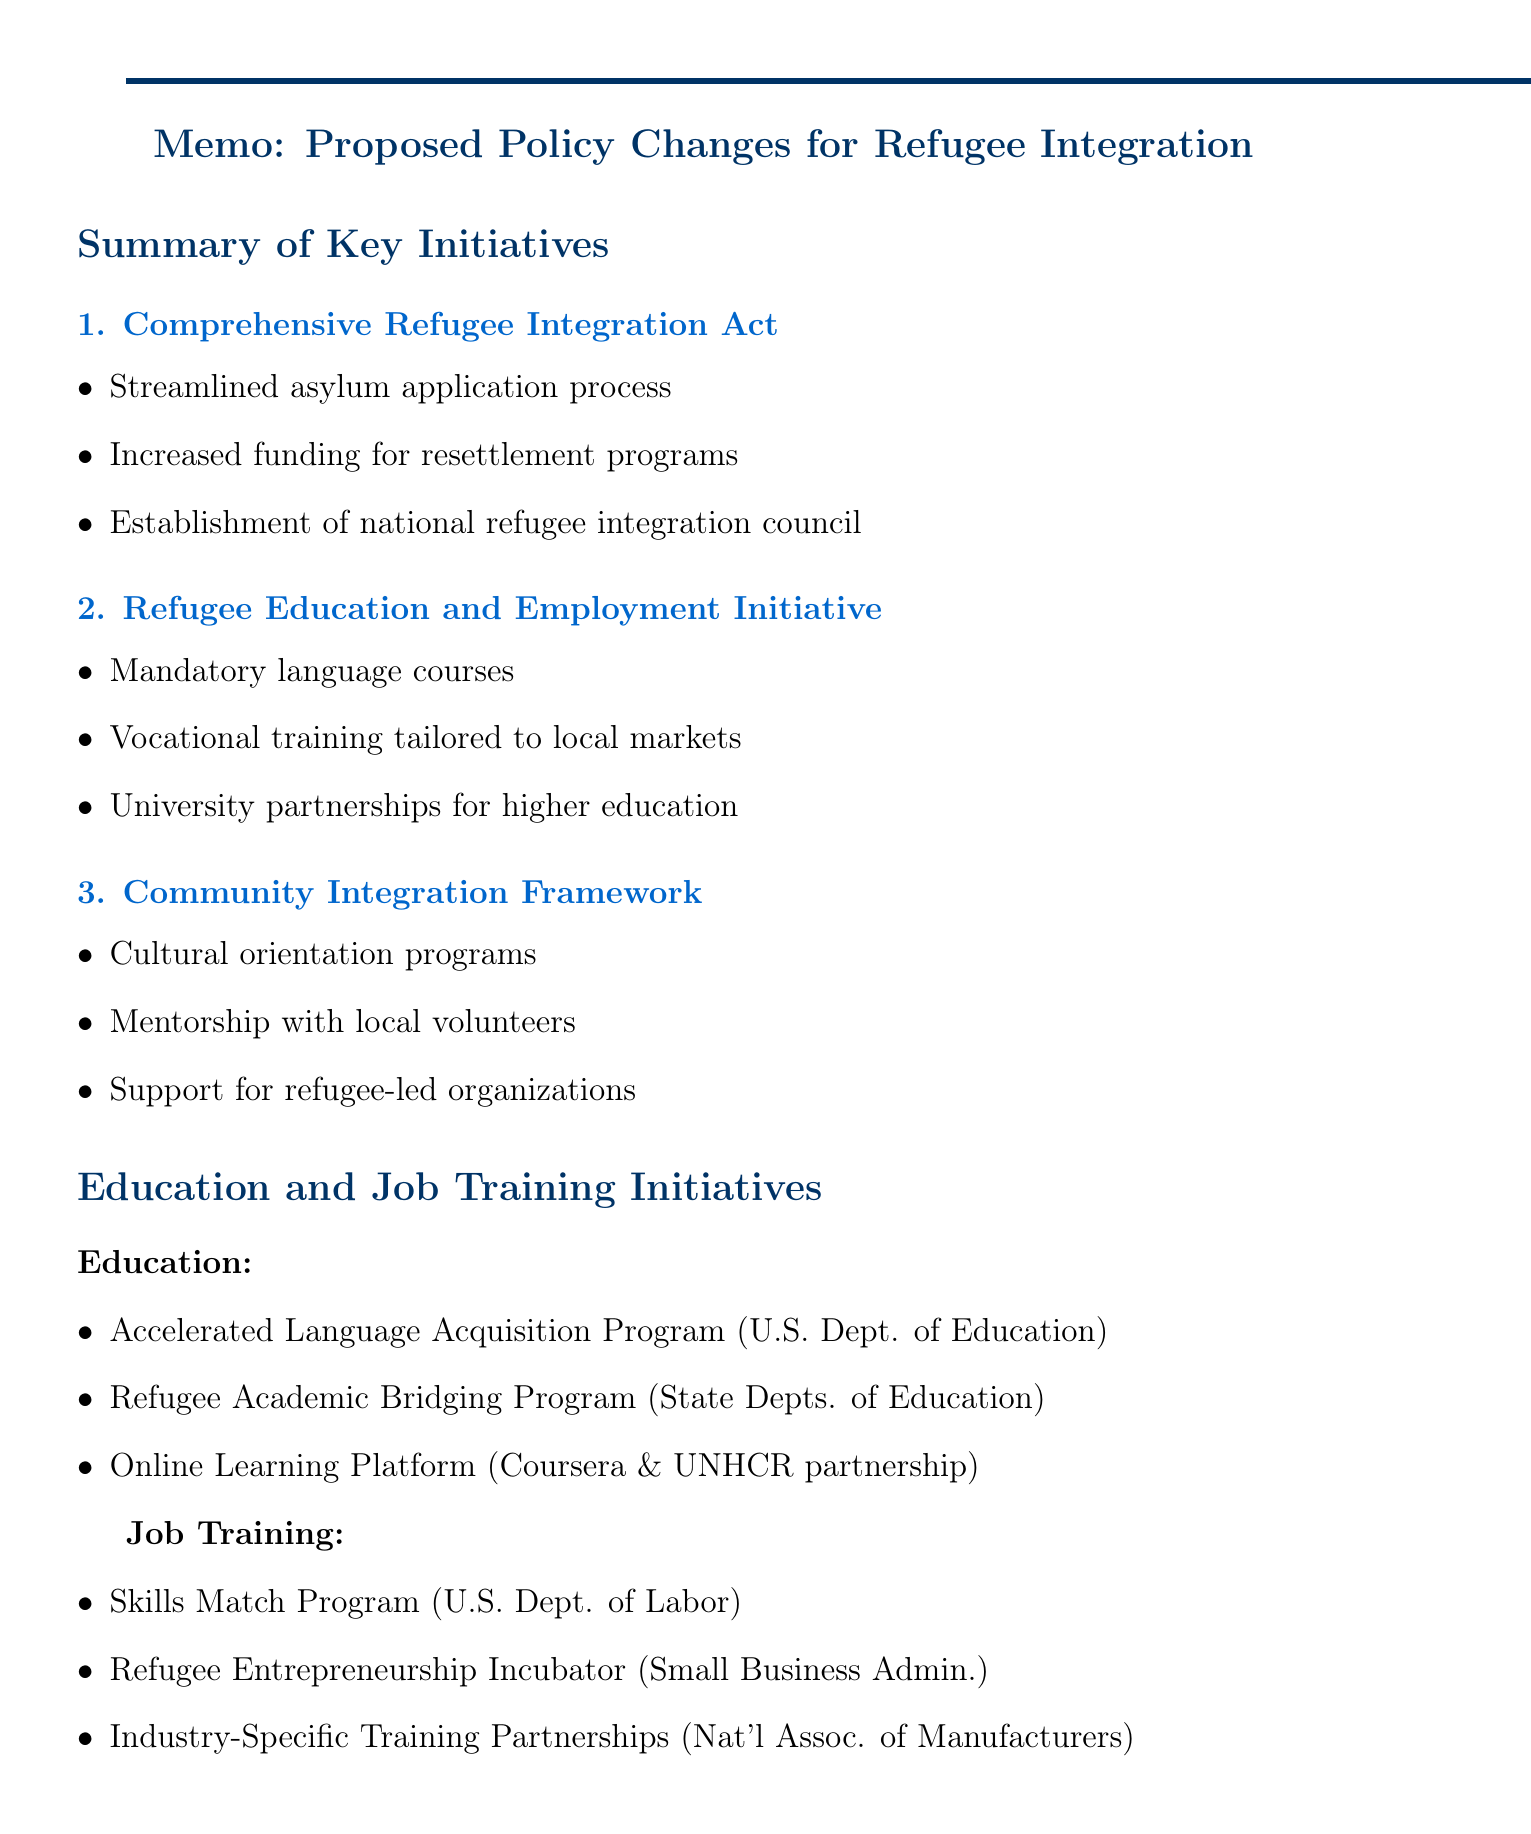What is the first proposed policy change? The document lists several proposed policies, with the first being the "Comprehensive Refugee Integration Act."
Answer: Comprehensive Refugee Integration Act What is the funding focus of the Refugee Education and Employment Initiative? This initiative emphasizes mandatory language courses and vocational training programs for refugees.
Answer: Mandatory language courses What does the Accelerated Language Acquisition Program aim to achieve? This program is designed to bring refugees to functional proficiency within a set timeframe.
Answer: Functional proficiency within 6 months How many new refugee-owned businesses are expected within five years? The document forecasts a specific number of anticipated businesses as a result of the proposed changes.
Answer: 500 Which U.S. department implements the Skills Match Program? The memo identifies the relevant department responsible for the implementation of this training program.
Answer: U.S. Department of Labor What type of cultural programs are included in the Community Integration Framework? This framework includes orientations designed to help refugees adapt to the host culture.
Answer: Cultural orientation programs What is the projected increase in refugee employment rate within two years? The memo provides an estimate related to employment rates for refugees following the implementation.
Answer: 25% What is a major challenge to implementing the proposed policies? The document outlines several challenges, including local resistance to refugee resettlement.
Answer: Local resistance to refugee resettlement 